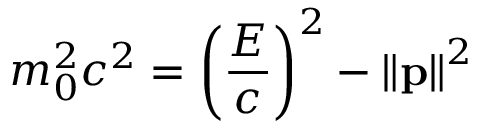Convert formula to latex. <formula><loc_0><loc_0><loc_500><loc_500>m _ { 0 } ^ { 2 } c ^ { 2 } = \left ( { \frac { E } { c } } \right ) ^ { 2 } - \left \| p \right \| ^ { 2 }</formula> 